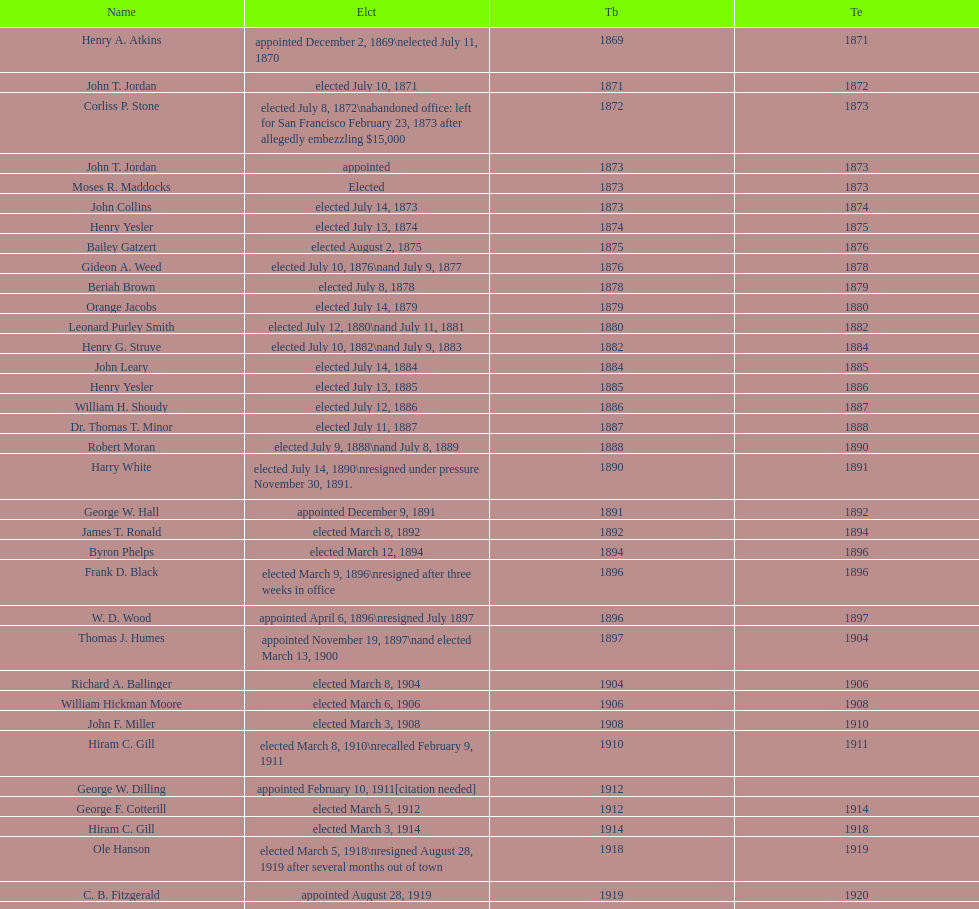Who began their term in 1890? Harry White. Could you parse the entire table as a dict? {'header': ['Name', 'Elct', 'Tb', 'Te'], 'rows': [['Henry A. Atkins', 'appointed December 2, 1869\\nelected July 11, 1870', '1869', '1871'], ['John T. Jordan', 'elected July 10, 1871', '1871', '1872'], ['Corliss P. Stone', 'elected July 8, 1872\\nabandoned office: left for San Francisco February 23, 1873 after allegedly embezzling $15,000', '1872', '1873'], ['John T. Jordan', 'appointed', '1873', '1873'], ['Moses R. Maddocks', 'Elected', '1873', '1873'], ['John Collins', 'elected July 14, 1873', '1873', '1874'], ['Henry Yesler', 'elected July 13, 1874', '1874', '1875'], ['Bailey Gatzert', 'elected August 2, 1875', '1875', '1876'], ['Gideon A. Weed', 'elected July 10, 1876\\nand July 9, 1877', '1876', '1878'], ['Beriah Brown', 'elected July 8, 1878', '1878', '1879'], ['Orange Jacobs', 'elected July 14, 1879', '1879', '1880'], ['Leonard Purley Smith', 'elected July 12, 1880\\nand July 11, 1881', '1880', '1882'], ['Henry G. Struve', 'elected July 10, 1882\\nand July 9, 1883', '1882', '1884'], ['John Leary', 'elected July 14, 1884', '1884', '1885'], ['Henry Yesler', 'elected July 13, 1885', '1885', '1886'], ['William H. Shoudy', 'elected July 12, 1886', '1886', '1887'], ['Dr. Thomas T. Minor', 'elected July 11, 1887', '1887', '1888'], ['Robert Moran', 'elected July 9, 1888\\nand July 8, 1889', '1888', '1890'], ['Harry White', 'elected July 14, 1890\\nresigned under pressure November 30, 1891.', '1890', '1891'], ['George W. Hall', 'appointed December 9, 1891', '1891', '1892'], ['James T. Ronald', 'elected March 8, 1892', '1892', '1894'], ['Byron Phelps', 'elected March 12, 1894', '1894', '1896'], ['Frank D. Black', 'elected March 9, 1896\\nresigned after three weeks in office', '1896', '1896'], ['W. D. Wood', 'appointed April 6, 1896\\nresigned July 1897', '1896', '1897'], ['Thomas J. Humes', 'appointed November 19, 1897\\nand elected March 13, 1900', '1897', '1904'], ['Richard A. Ballinger', 'elected March 8, 1904', '1904', '1906'], ['William Hickman Moore', 'elected March 6, 1906', '1906', '1908'], ['John F. Miller', 'elected March 3, 1908', '1908', '1910'], ['Hiram C. Gill', 'elected March 8, 1910\\nrecalled February 9, 1911', '1910', '1911'], ['George W. Dilling', 'appointed February 10, 1911[citation needed]', '1912', ''], ['George F. Cotterill', 'elected March 5, 1912', '1912', '1914'], ['Hiram C. Gill', 'elected March 3, 1914', '1914', '1918'], ['Ole Hanson', 'elected March 5, 1918\\nresigned August 28, 1919 after several months out of town', '1918', '1919'], ['C. B. Fitzgerald', 'appointed August 28, 1919', '1919', '1920'], ['Hugh M. Caldwell', 'elected March 2, 1920', '1920', '1922'], ['Edwin J. Brown', 'elected May 2, 1922\\nand March 4, 1924', '1922', '1926'], ['Bertha Knight Landes', 'elected March 9, 1926', '1926', '1928'], ['Frank E. Edwards', 'elected March 6, 1928\\nand March 4, 1930\\nrecalled July 13, 1931', '1928', '1931'], ['Robert H. Harlin', 'appointed July 14, 1931', '1931', '1932'], ['John F. Dore', 'elected March 8, 1932', '1932', '1934'], ['Charles L. Smith', 'elected March 6, 1934', '1934', '1936'], ['John F. Dore', 'elected March 3, 1936\\nbecame gravely ill and was relieved of office April 13, 1938, already a lame duck after the 1938 election. He died five days later.', '1936', '1938'], ['Arthur B. Langlie', "elected March 8, 1938\\nappointed to take office early, April 27, 1938, after Dore's death.\\nelected March 5, 1940\\nresigned January 11, 1941, to become Governor of Washington", '1938', '1941'], ['John E. Carroll', 'appointed January 27, 1941', '1941', '1941'], ['Earl Millikin', 'elected March 4, 1941', '1941', '1942'], ['William F. Devin', 'elected March 3, 1942, March 7, 1944, March 5, 1946, and March 2, 1948', '1942', '1952'], ['Allan Pomeroy', 'elected March 4, 1952', '1952', '1956'], ['Gordon S. Clinton', 'elected March 6, 1956\\nand March 8, 1960', '1956', '1964'], ["James d'Orma Braman", 'elected March 10, 1964\\nresigned March 23, 1969, to accept an appointment as an Assistant Secretary in the Department of Transportation in the Nixon administration.', '1964', '1969'], ['Floyd C. Miller', 'appointed March 23, 1969', '1969', '1969'], ['Wesley C. Uhlman', 'elected November 4, 1969\\nand November 6, 1973\\nsurvived recall attempt on July 1, 1975', 'December 1, 1969', 'January 1, 1978'], ['Charles Royer', 'elected November 8, 1977, November 3, 1981, and November 5, 1985', 'January 1, 1978', 'January 1, 1990'], ['Norman B. Rice', 'elected November 7, 1989', 'January 1, 1990', 'January 1, 1998'], ['Paul Schell', 'elected November 4, 1997', 'January 1, 1998', 'January 1, 2002'], ['Gregory J. Nickels', 'elected November 6, 2001\\nand November 8, 2005', 'January 1, 2002', 'January 1, 2010'], ['Michael McGinn', 'elected November 3, 2009', 'January 1, 2010', 'January 1, 2014'], ['Ed Murray', 'elected November 5, 2013', 'January 1, 2014', 'present']]} 